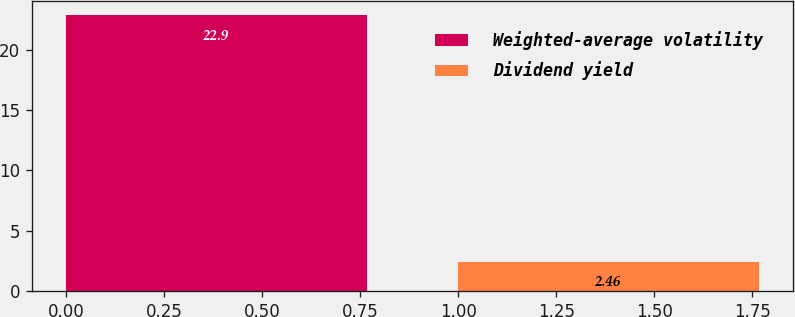Convert chart to OTSL. <chart><loc_0><loc_0><loc_500><loc_500><bar_chart><fcel>Weighted-average volatility<fcel>Dividend yield<nl><fcel>22.9<fcel>2.46<nl></chart> 